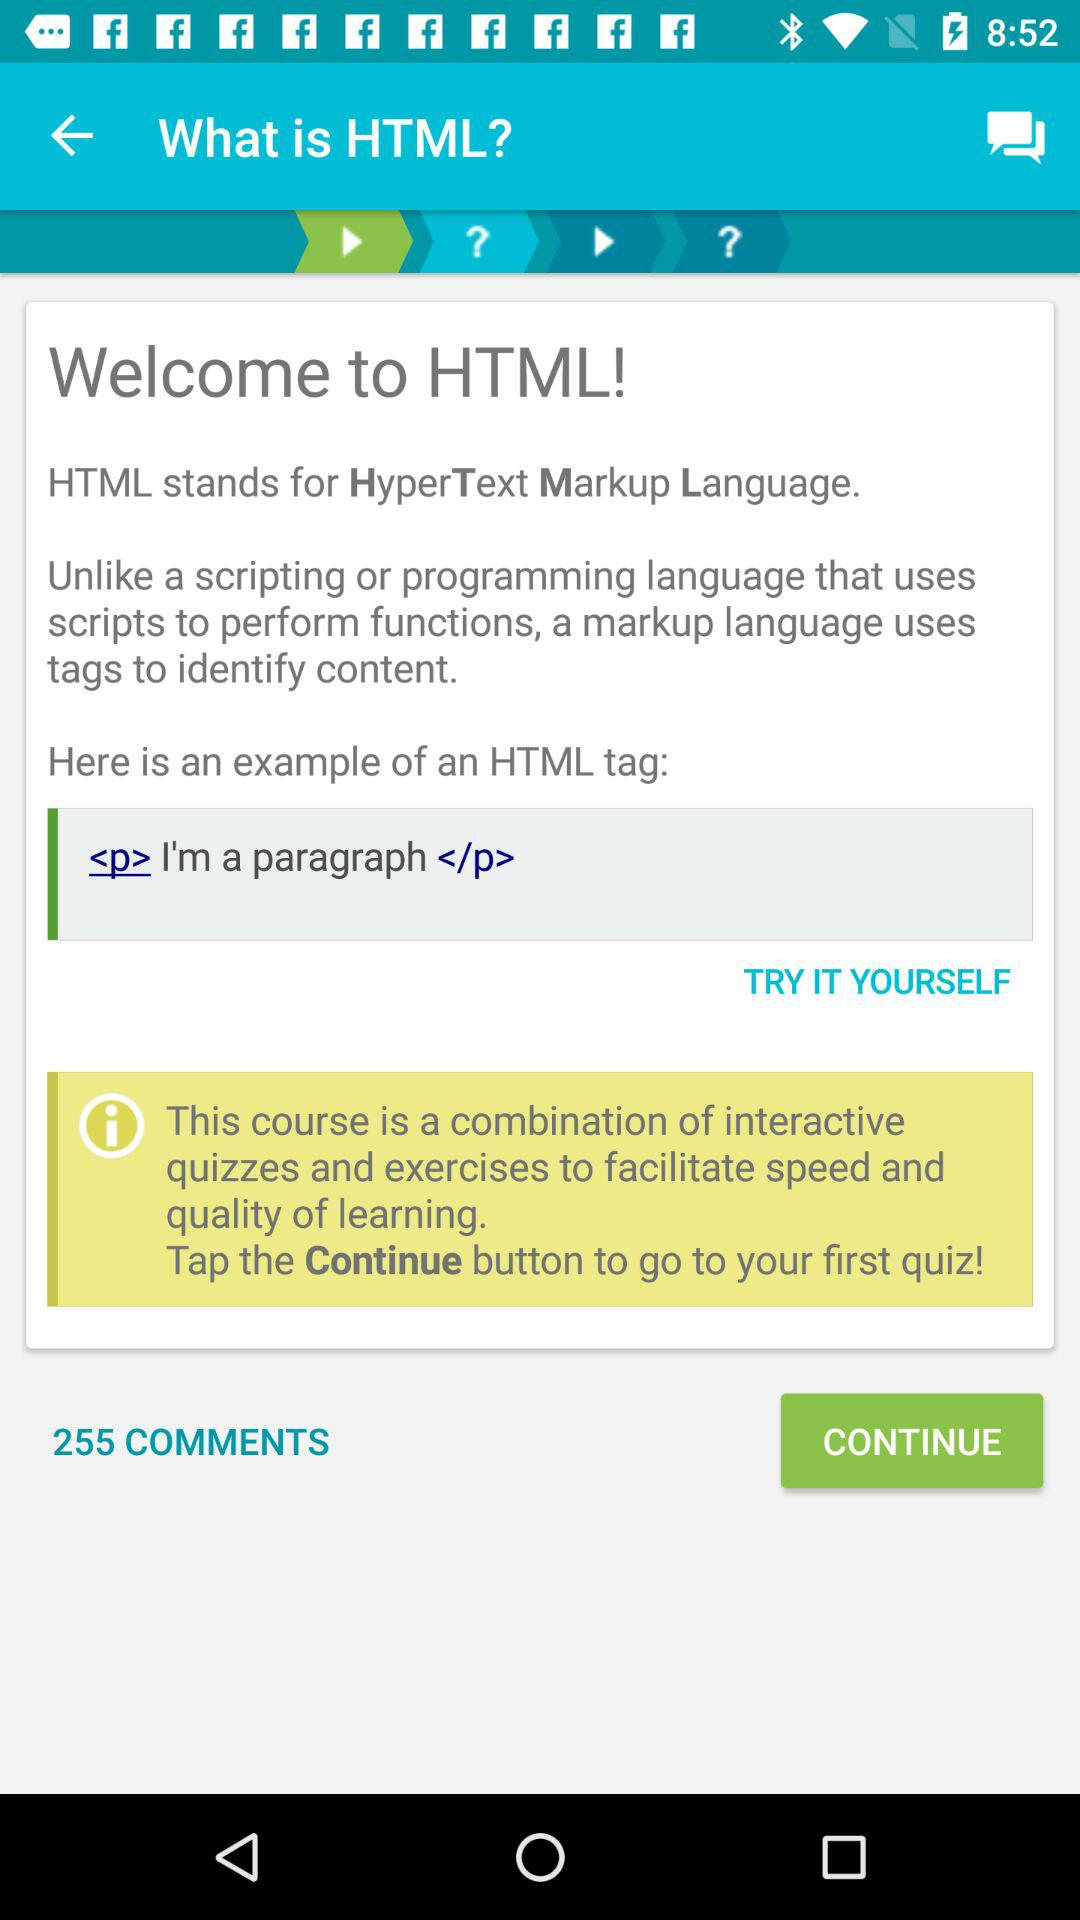How many comments in total are there? There are 255 comments in total. 